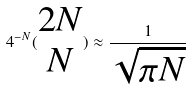<formula> <loc_0><loc_0><loc_500><loc_500>4 ^ { - N } ( \begin{matrix} 2 N \\ N \end{matrix} ) \approx \frac { 1 } { \sqrt { \pi N } }</formula> 